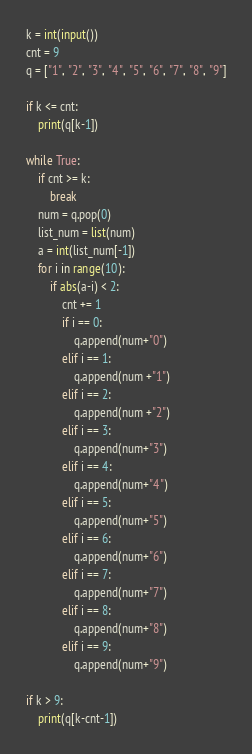Convert code to text. <code><loc_0><loc_0><loc_500><loc_500><_Python_>k = int(input())
cnt = 9
q = ["1", "2", "3", "4", "5", "6", "7", "8", "9"]

if k <= cnt:
    print(q[k-1])

while True:
    if cnt >= k:
        break
    num = q.pop(0)
    list_num = list(num)
    a = int(list_num[-1])
    for i in range(10):
        if abs(a-i) < 2:
            cnt += 1
            if i == 0:
                q.append(num+"0")
            elif i == 1:
                q.append(num +"1")
            elif i == 2:
                q.append(num +"2")
            elif i == 3:
                q.append(num+"3")
            elif i == 4:
                q.append(num+"4")
            elif i == 5:
                q.append(num+"5")
            elif i == 6:
                q.append(num+"6")
            elif i == 7:
                q.append(num+"7")
            elif i == 8:
                q.append(num+"8")
            elif i == 9:
                q.append(num+"9")

if k > 9:
    print(q[k-cnt-1])</code> 